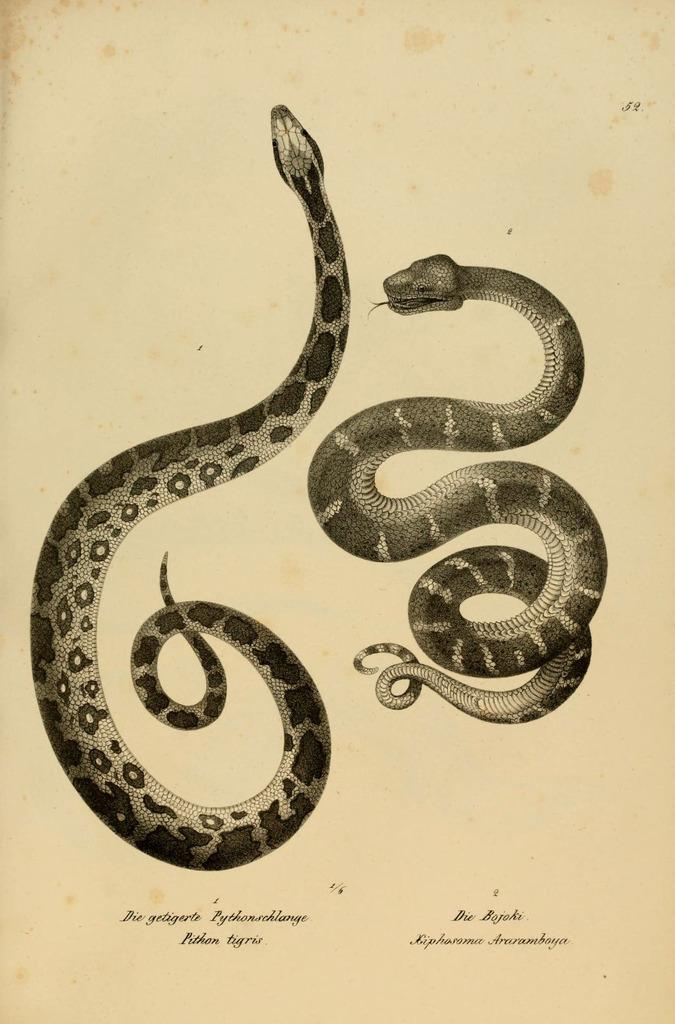What is depicted on the paper in the image? There are drawings of snakes on the paper. What other elements can be found on the paper besides the drawings? There are words and numbers on the paper. What type of shoes are being worn by the snakes in the image? There are no shoes present in the image, as it features drawings of snakes on a paper. 